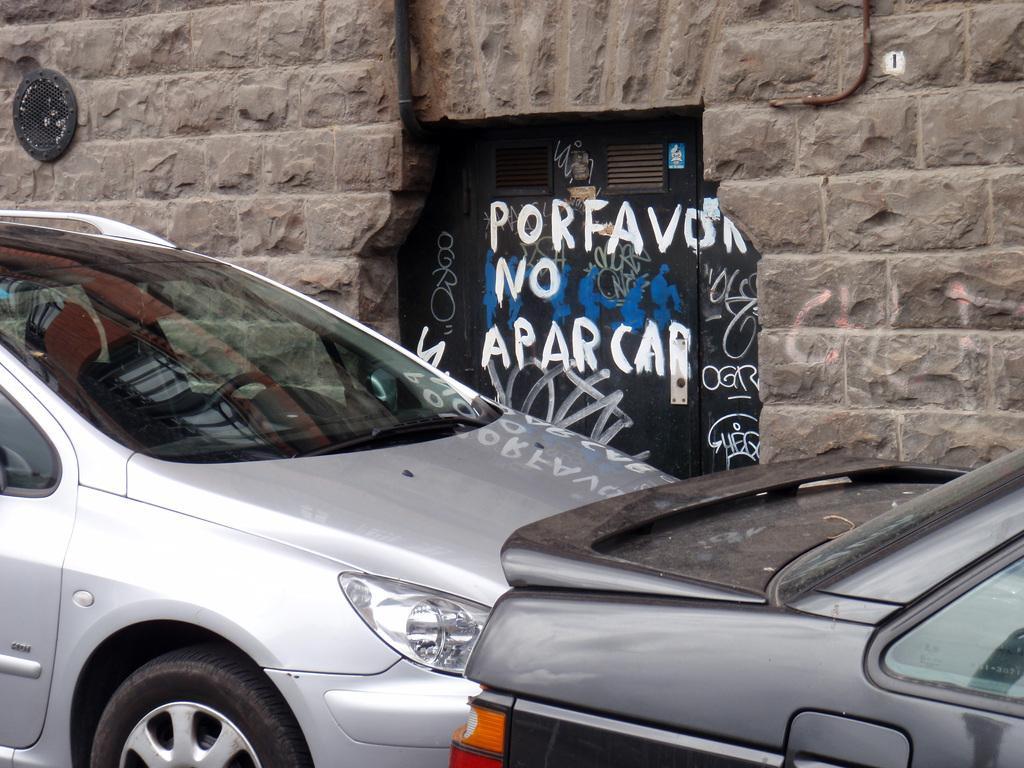Describe this image in one or two sentences. In this image on the foreground there are cars. In the background there is a wall. Here there is a door in the middle. On it few texts are there. 